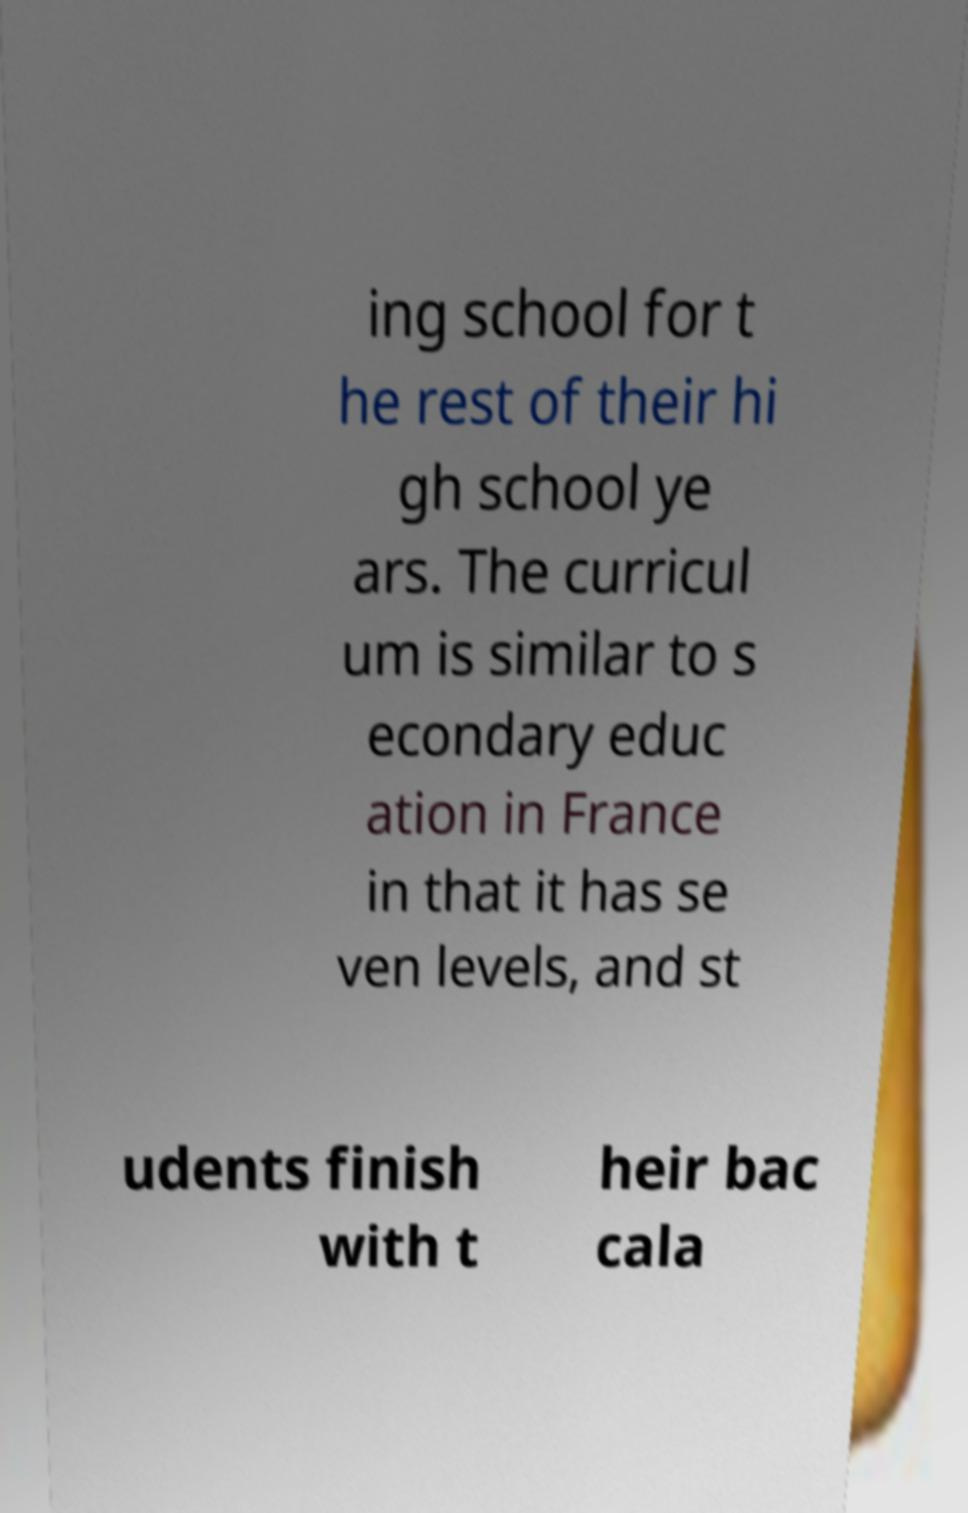Can you read and provide the text displayed in the image?This photo seems to have some interesting text. Can you extract and type it out for me? ing school for t he rest of their hi gh school ye ars. The curricul um is similar to s econdary educ ation in France in that it has se ven levels, and st udents finish with t heir bac cala 